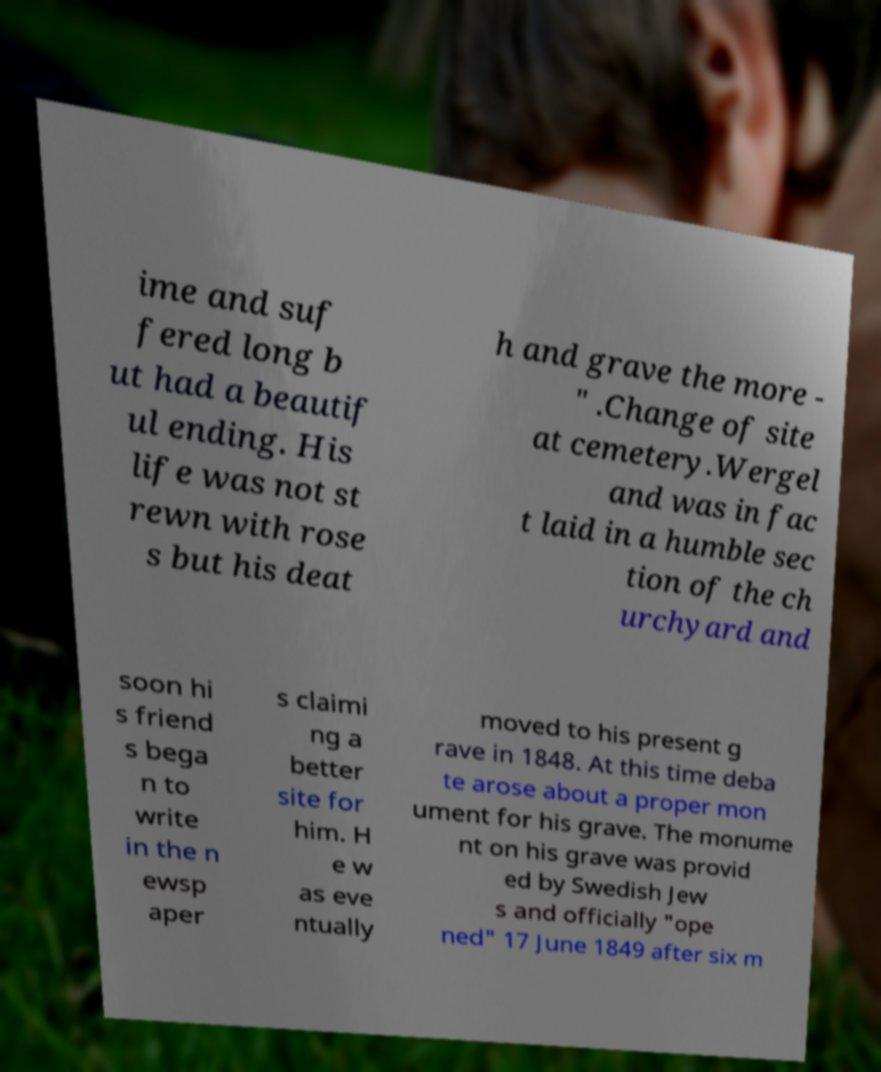I need the written content from this picture converted into text. Can you do that? ime and suf fered long b ut had a beautif ul ending. His life was not st rewn with rose s but his deat h and grave the more - " .Change of site at cemetery.Wergel and was in fac t laid in a humble sec tion of the ch urchyard and soon hi s friend s bega n to write in the n ewsp aper s claimi ng a better site for him. H e w as eve ntually moved to his present g rave in 1848. At this time deba te arose about a proper mon ument for his grave. The monume nt on his grave was provid ed by Swedish Jew s and officially "ope ned" 17 June 1849 after six m 